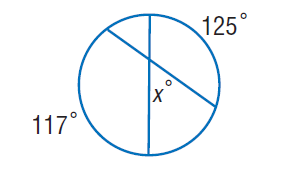Answer the mathemtical geometry problem and directly provide the correct option letter.
Question: Find x.
Choices: A: 59 B: 117 C: 125 D: 342 A 